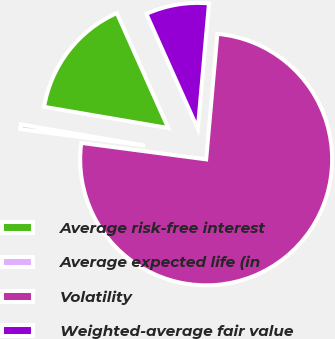Convert chart to OTSL. <chart><loc_0><loc_0><loc_500><loc_500><pie_chart><fcel>Average risk-free interest<fcel>Average expected life (in<fcel>Volatility<fcel>Weighted-average fair value<nl><fcel>15.62%<fcel>0.6%<fcel>75.68%<fcel>8.11%<nl></chart> 